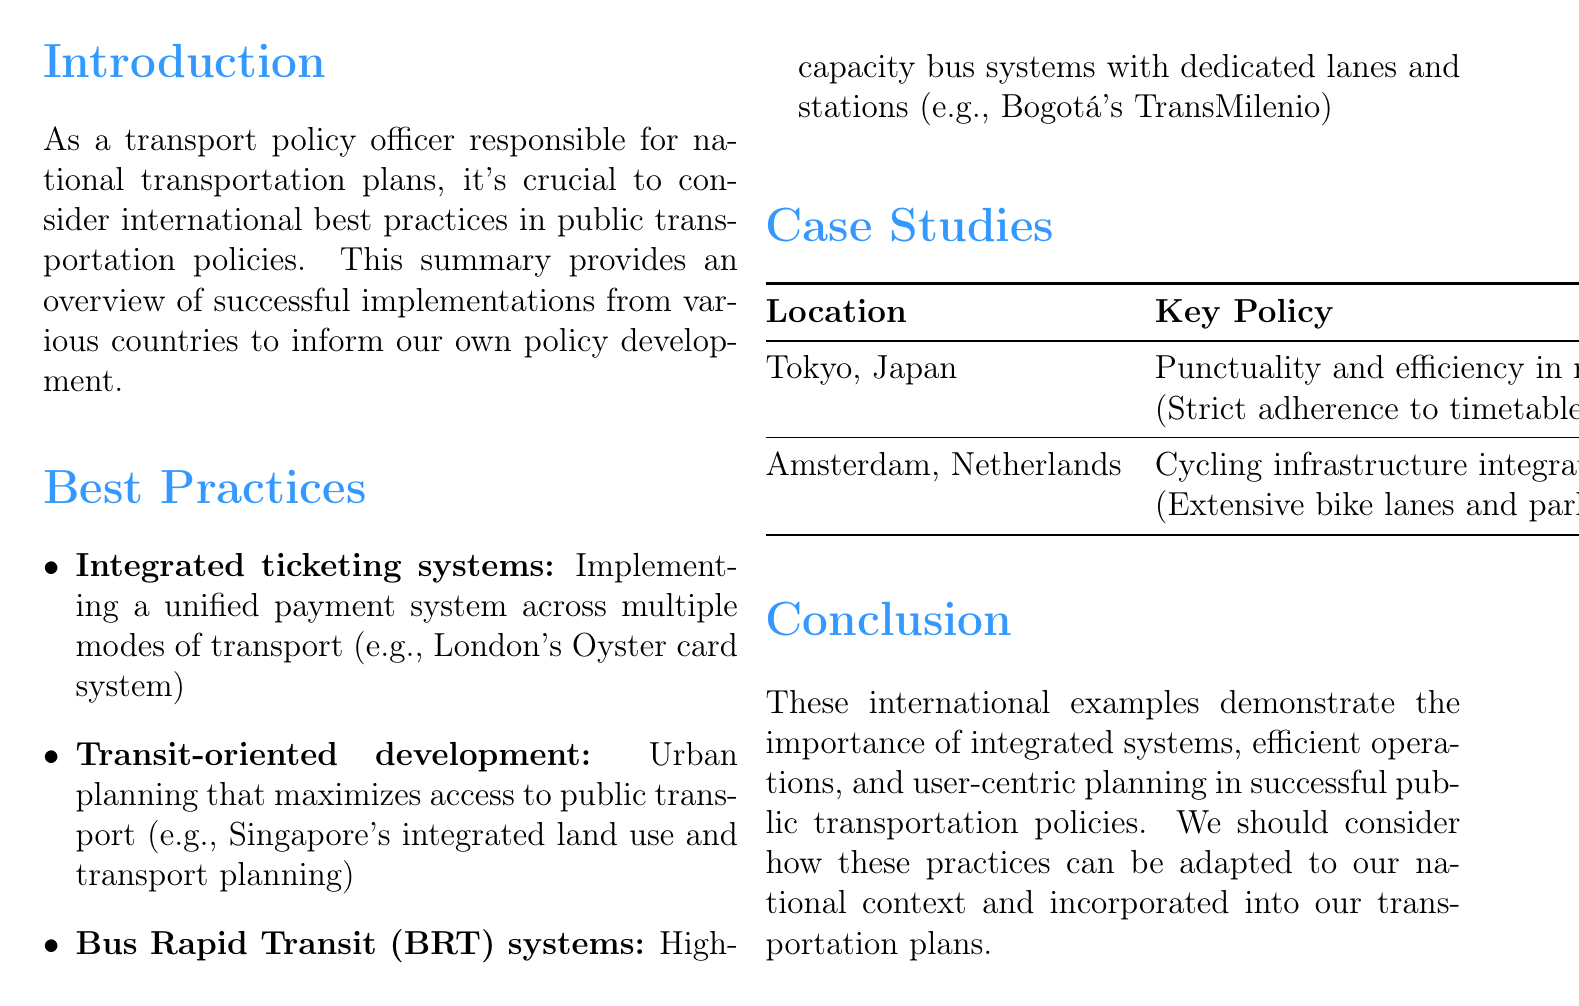What is the title of the document? The title of the document is prominently displayed at the top.
Answer: International Best Practices in Public Transportation What is one example of an integrated ticketing system? The document provides a specific example related to integrated ticketing systems.
Answer: London's Oyster card system Which city in the Netherlands is mentioned in the case studies? The case studies section indicates a specific city in the Netherlands.
Answer: Amsterdam What key policy is highlighted for Tokyo? The case study section provides this specific key policy for Tokyo.
Answer: Punctuality and efficiency in rail systems What does transit-oriented development focus on? The description of this best practice explains its main focus.
Answer: Maximizes access to public transport What is the main idea of the conclusion? The conclusion summarizes the overall message conveyed throughout the document.
Answer: Importance of integrated systems, efficient operations, and user-centric planning Which transportation feature is emphasized in Amsterdam's case study? The document specifies a particular feature related to Amsterdam’s cycling policy.
Answer: Cycling infrastructure integration How many best practices are listed? The document lists a certain number of best practices under that section.
Answer: Three 